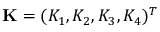<formula> <loc_0><loc_0><loc_500><loc_500>K = ( K _ { 1 } , K _ { 2 } , K _ { 3 } , K _ { 4 } ) ^ { T }</formula> 